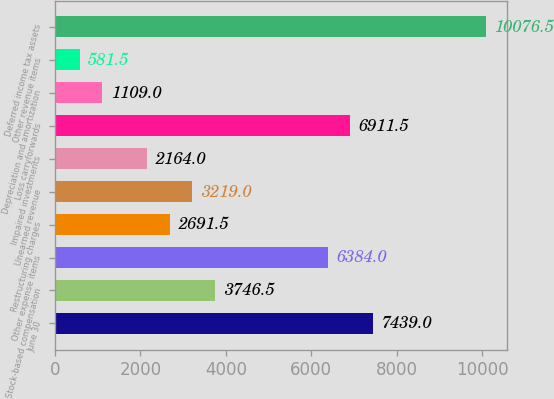<chart> <loc_0><loc_0><loc_500><loc_500><bar_chart><fcel>June 30<fcel>Stock-based compensation<fcel>Other expense items<fcel>Restructuring charges<fcel>Unearned revenue<fcel>Impaired investments<fcel>Loss carryforwards<fcel>Depreciation and amortization<fcel>Other revenue items<fcel>Deferred income tax assets<nl><fcel>7439<fcel>3746.5<fcel>6384<fcel>2691.5<fcel>3219<fcel>2164<fcel>6911.5<fcel>1109<fcel>581.5<fcel>10076.5<nl></chart> 